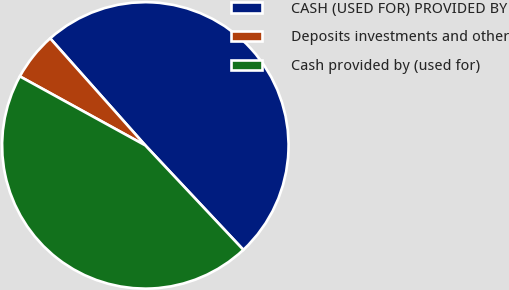<chart> <loc_0><loc_0><loc_500><loc_500><pie_chart><fcel>CASH (USED FOR) PROVIDED BY<fcel>Deposits investments and other<fcel>Cash provided by (used for)<nl><fcel>49.57%<fcel>5.43%<fcel>45.0%<nl></chart> 